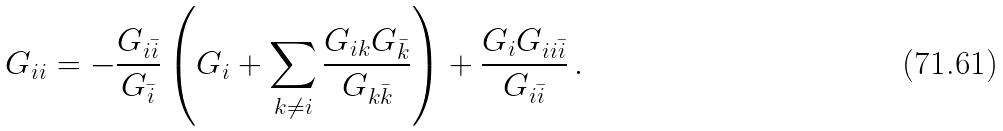Convert formula to latex. <formula><loc_0><loc_0><loc_500><loc_500>G _ { i i } = - \frac { G _ { i \bar { i } } } { G _ { \bar { i } } } \left ( G _ { i } + \sum _ { k \neq i } \frac { G _ { i k } G _ { \bar { k } } } { G _ { k \bar { k } } } \right ) + \frac { G _ { i } G _ { i i \bar { i } } } { G _ { i \bar { i } } } \, .</formula> 